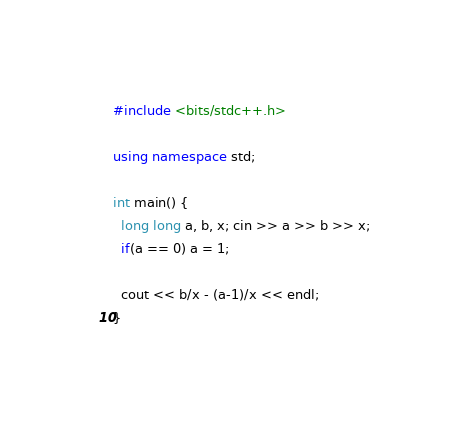<code> <loc_0><loc_0><loc_500><loc_500><_C++_>#include <bits/stdc++.h>

using namespace std;

int main() {
  long long a, b, x; cin >> a >> b >> x;
  if(a == 0) a = 1;

  cout << b/x - (a-1)/x << endl;
}
</code> 